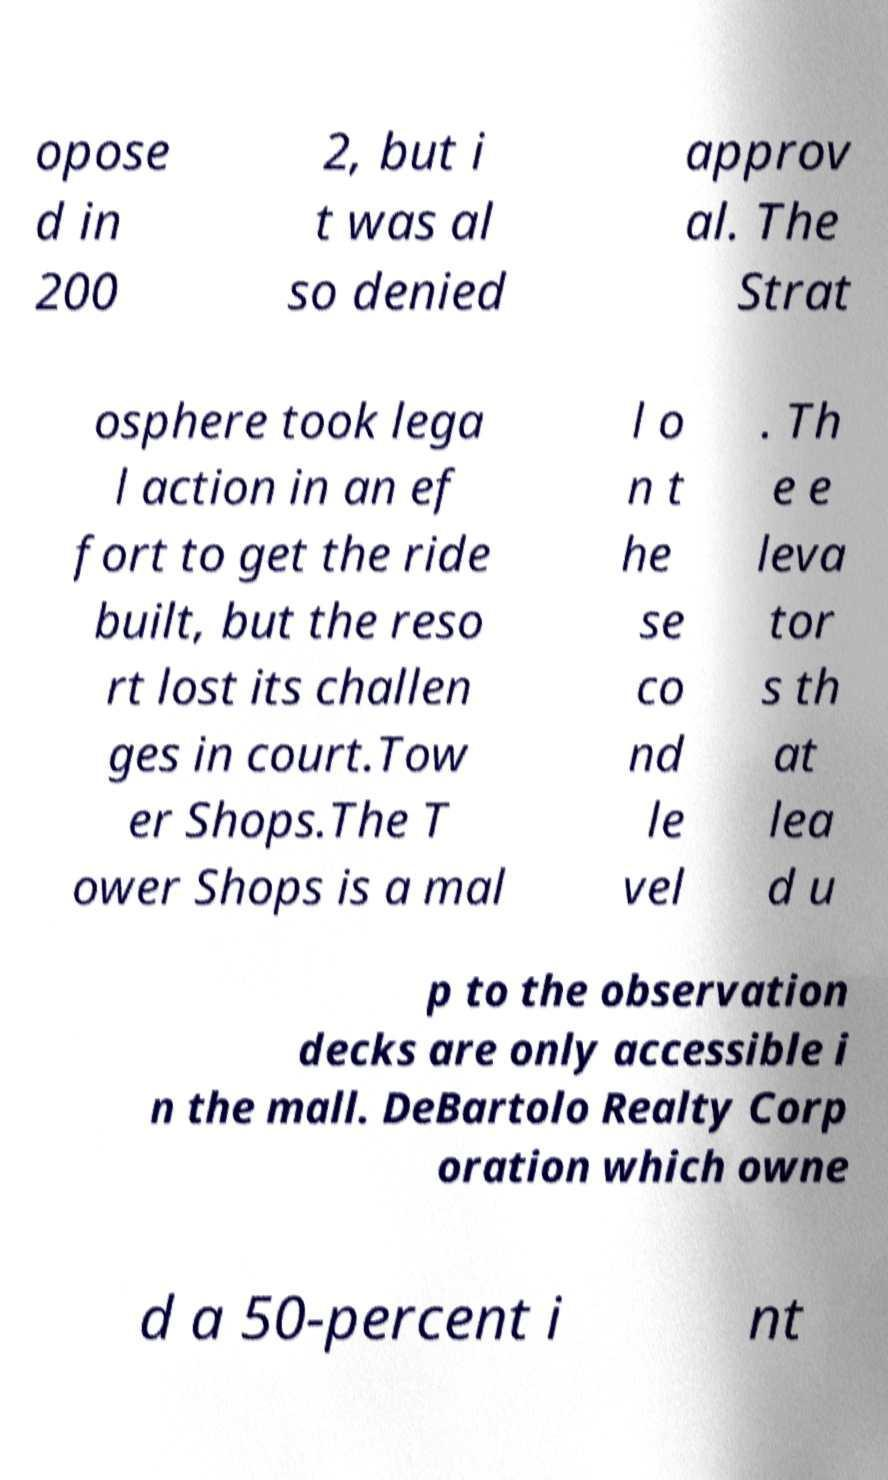For documentation purposes, I need the text within this image transcribed. Could you provide that? opose d in 200 2, but i t was al so denied approv al. The Strat osphere took lega l action in an ef fort to get the ride built, but the reso rt lost its challen ges in court.Tow er Shops.The T ower Shops is a mal l o n t he se co nd le vel . Th e e leva tor s th at lea d u p to the observation decks are only accessible i n the mall. DeBartolo Realty Corp oration which owne d a 50-percent i nt 